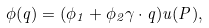Convert formula to latex. <formula><loc_0><loc_0><loc_500><loc_500>\phi ( { q } ) = ( \phi _ { 1 } + \phi _ { 2 } { \gamma } \cdot { q } ) u ( P ) ,</formula> 